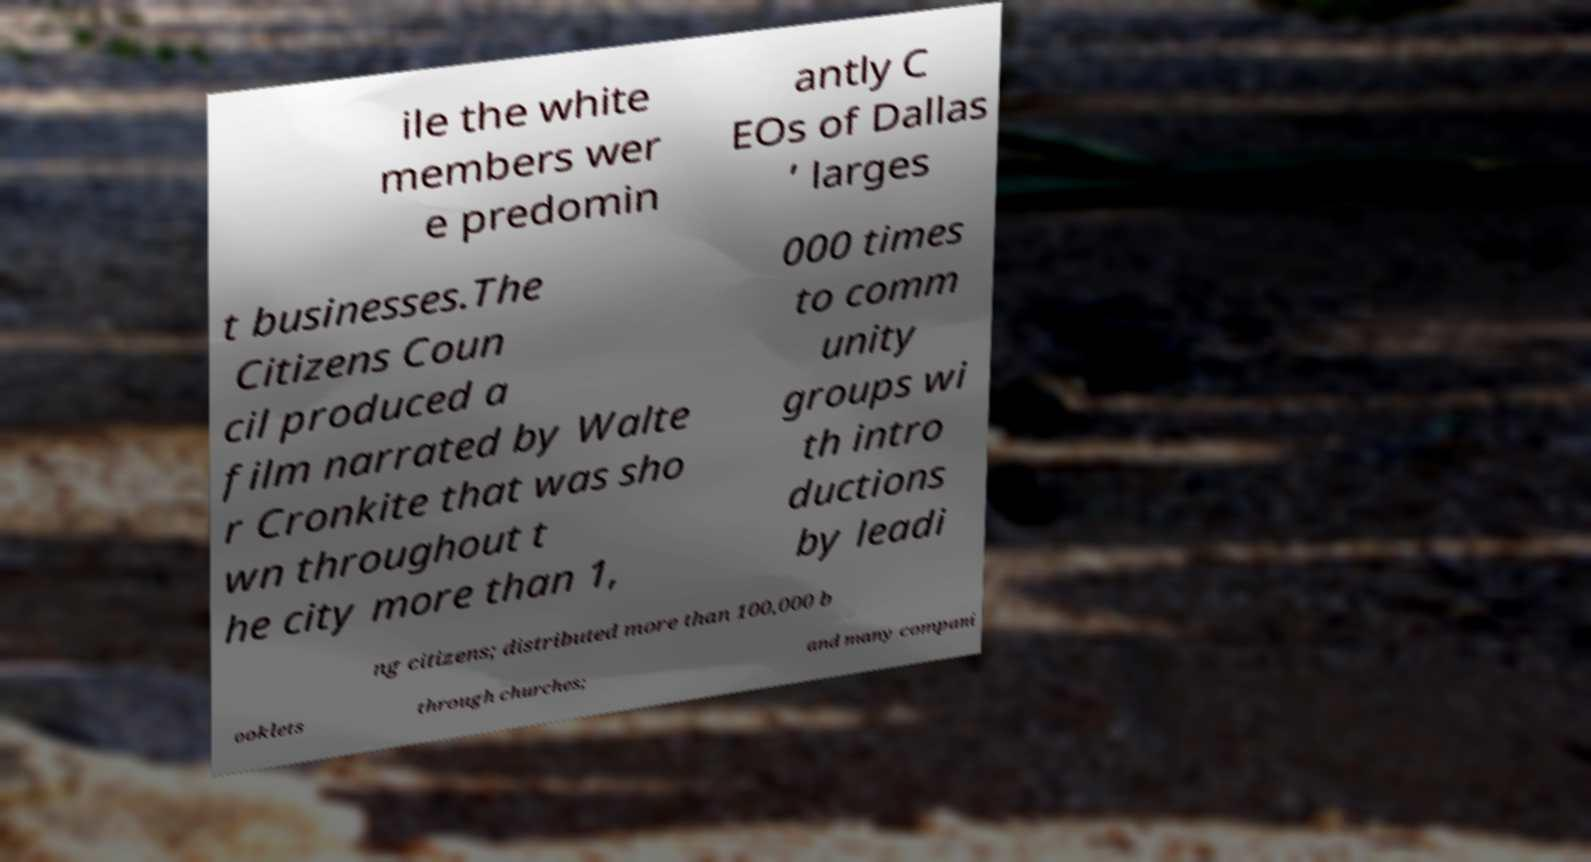There's text embedded in this image that I need extracted. Can you transcribe it verbatim? ile the white members wer e predomin antly C EOs of Dallas ’ larges t businesses.The Citizens Coun cil produced a film narrated by Walte r Cronkite that was sho wn throughout t he city more than 1, 000 times to comm unity groups wi th intro ductions by leadi ng citizens; distributed more than 100,000 b ooklets through churches; and many compani 